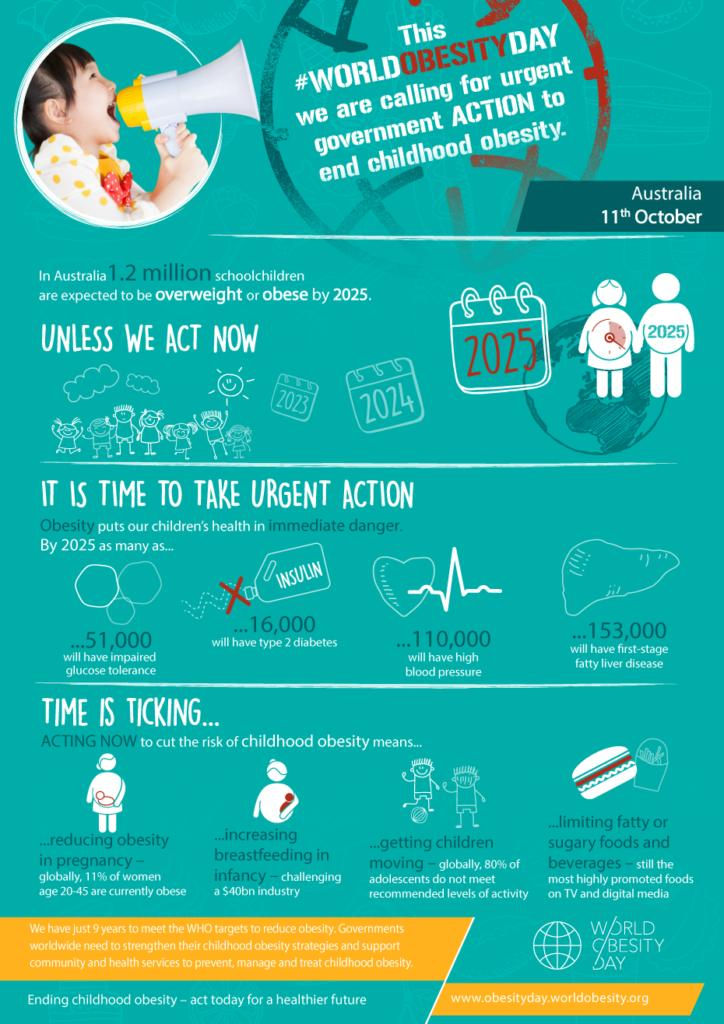Indicate a few pertinent items in this graphic. Obesity can be caused by the consumption of fatty or sugary snacks and beverages. It is predicted that by the year 2050, approximately 16,000 children will be diagnosed with Type 2 diabetes. By the year 2050, it is projected that approximately 110,000 children will be diagnosed with increased blood pressure. By the year 2050, it is projected that approximately 51,000 children will be diagnosed with high glucose levels, according to estimates. The second method mentioned in the infographic to prevent obesity is increasing breastfeeding in infancy. 